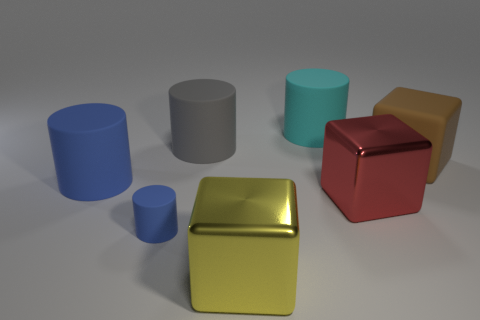Subtract all cubes. How many objects are left? 4 Subtract all tiny blue matte cylinders. How many cylinders are left? 3 Subtract all brown cubes. How many cubes are left? 2 Subtract 0 green cylinders. How many objects are left? 7 Subtract 1 blocks. How many blocks are left? 2 Subtract all purple cubes. Subtract all cyan cylinders. How many cubes are left? 3 Subtract all red spheres. How many brown blocks are left? 1 Subtract all matte blocks. Subtract all gray objects. How many objects are left? 5 Add 5 cyan cylinders. How many cyan cylinders are left? 6 Add 6 gray rubber objects. How many gray rubber objects exist? 7 